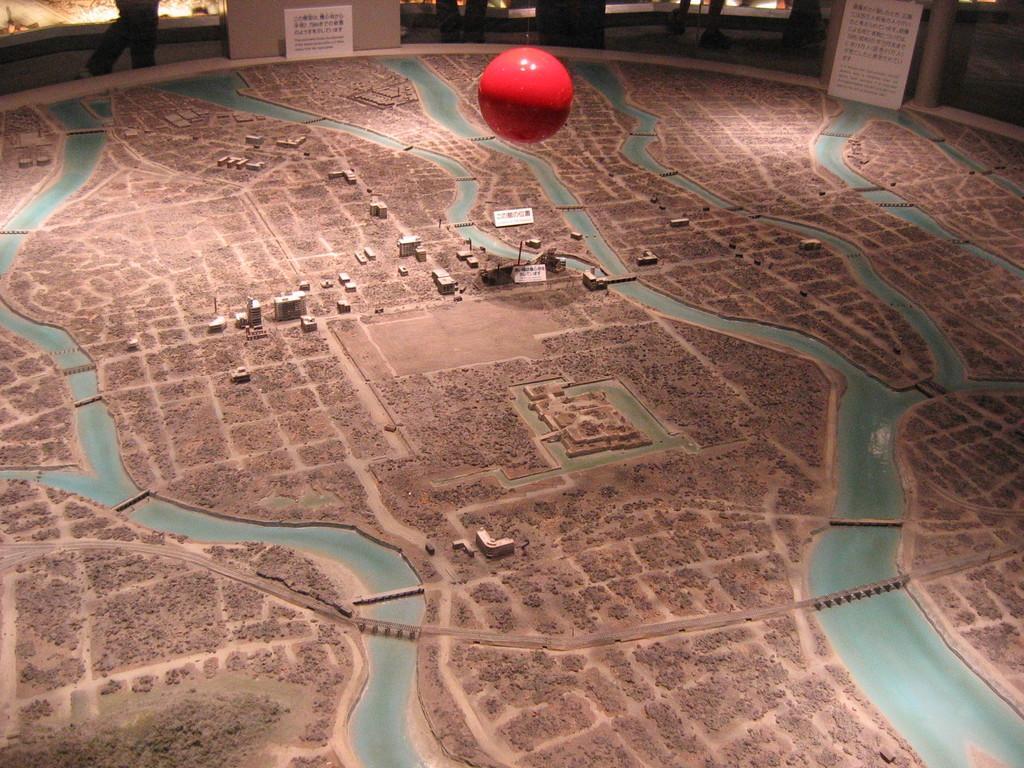Can you describe this image briefly? In this image I can see the aerial view and I can see few buildings. In the background I can see few people and I can also see the ball in red color. 